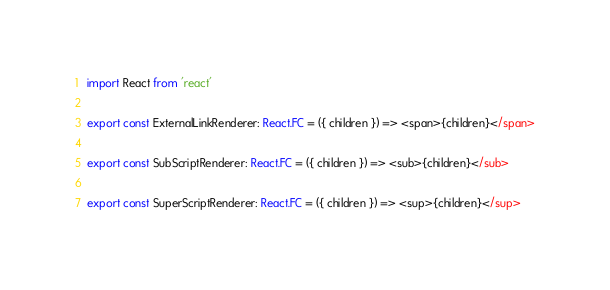Convert code to text. <code><loc_0><loc_0><loc_500><loc_500><_TypeScript_>import React from 'react'

export const ExternalLinkRenderer: React.FC = ({ children }) => <span>{children}</span>

export const SubScriptRenderer: React.FC = ({ children }) => <sub>{children}</sub>

export const SuperScriptRenderer: React.FC = ({ children }) => <sup>{children}</sup>
</code> 